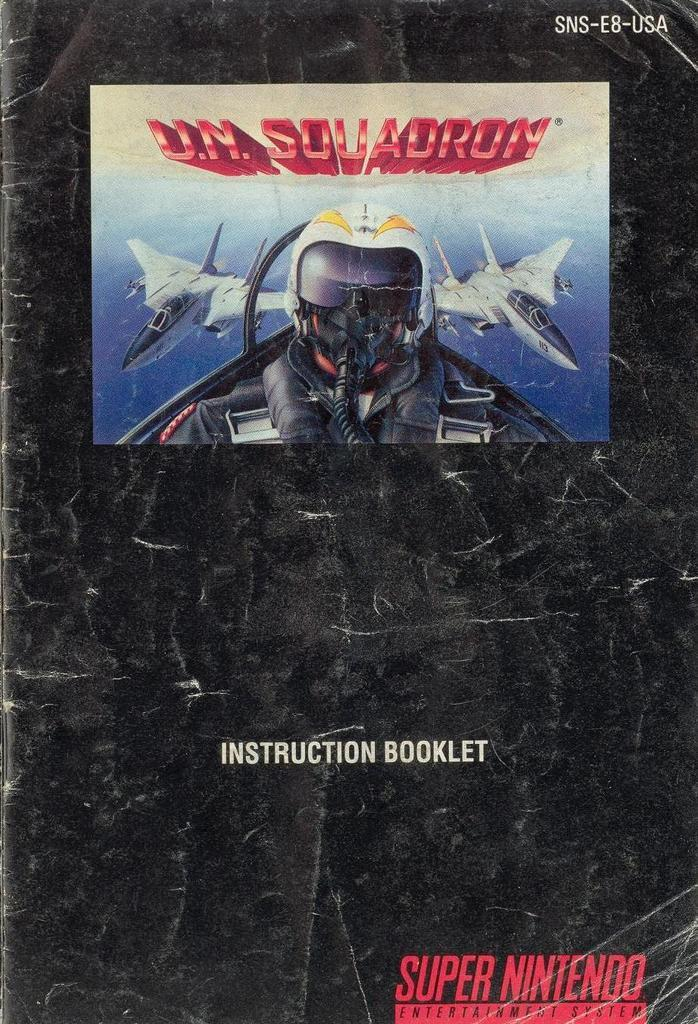<image>
Describe the image concisely. Instruction Booklet from Super Nintendo about U.N Squadron. 